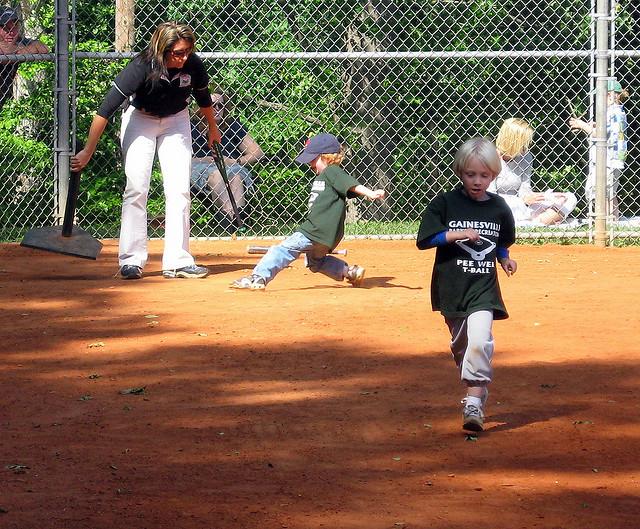Is the kid playing baseball?
Short answer required. Yes. Where is the tee-ball stand?
Keep it brief. In woman's hand. What is the boy in the blue hat doing?
Answer briefly. Sliding. 